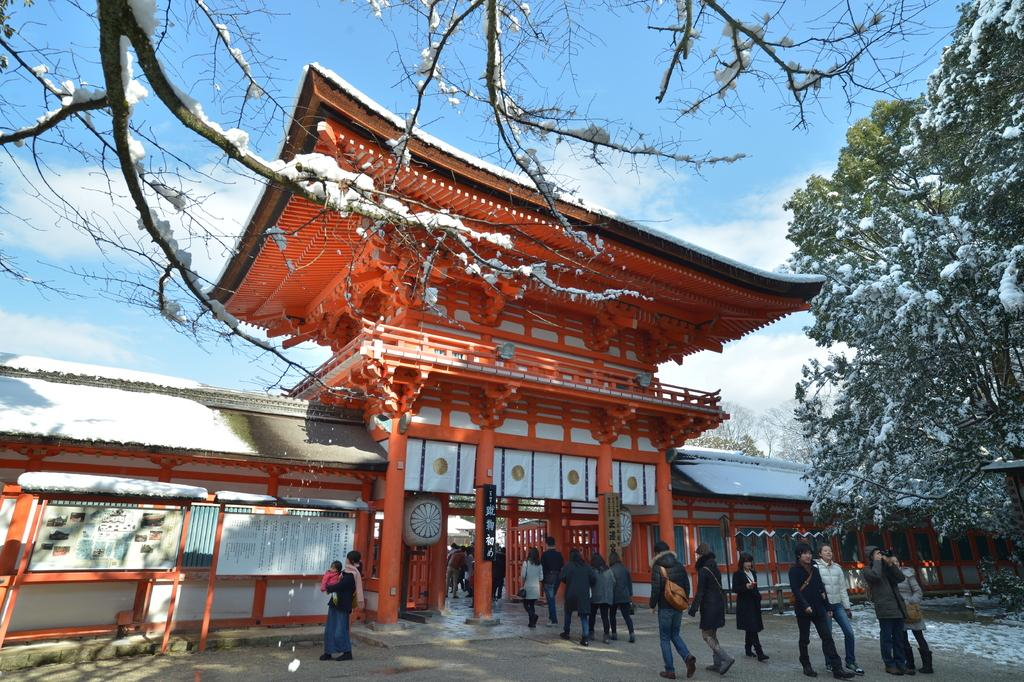What type of structure is present in the image? There is a building in the image. What other natural elements can be seen in the image? There are trees and snow visible in the image. What are the people in the image doing? The people in the image are walking. What can be seen in the background of the image? The sky is visible in the background of the image. Where can the map be found in the image? There is no map present in the image. What type of chalk is being used by the people walking in the image? There is no chalk visible in the image, and the people walking are not using any chalk. 